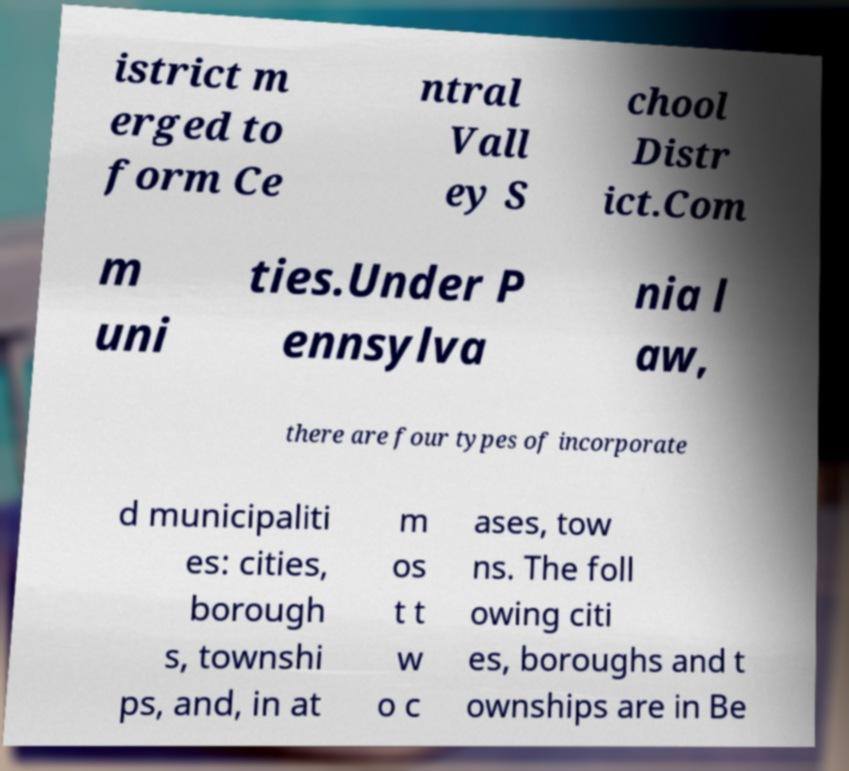Can you read and provide the text displayed in the image?This photo seems to have some interesting text. Can you extract and type it out for me? istrict m erged to form Ce ntral Vall ey S chool Distr ict.Com m uni ties.Under P ennsylva nia l aw, there are four types of incorporate d municipaliti es: cities, borough s, townshi ps, and, in at m os t t w o c ases, tow ns. The foll owing citi es, boroughs and t ownships are in Be 